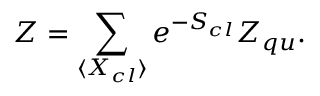<formula> <loc_0><loc_0><loc_500><loc_500>Z = \sum _ { \langle X _ { c l } \rangle } e ^ { - S _ { c l } } Z _ { q u } .</formula> 